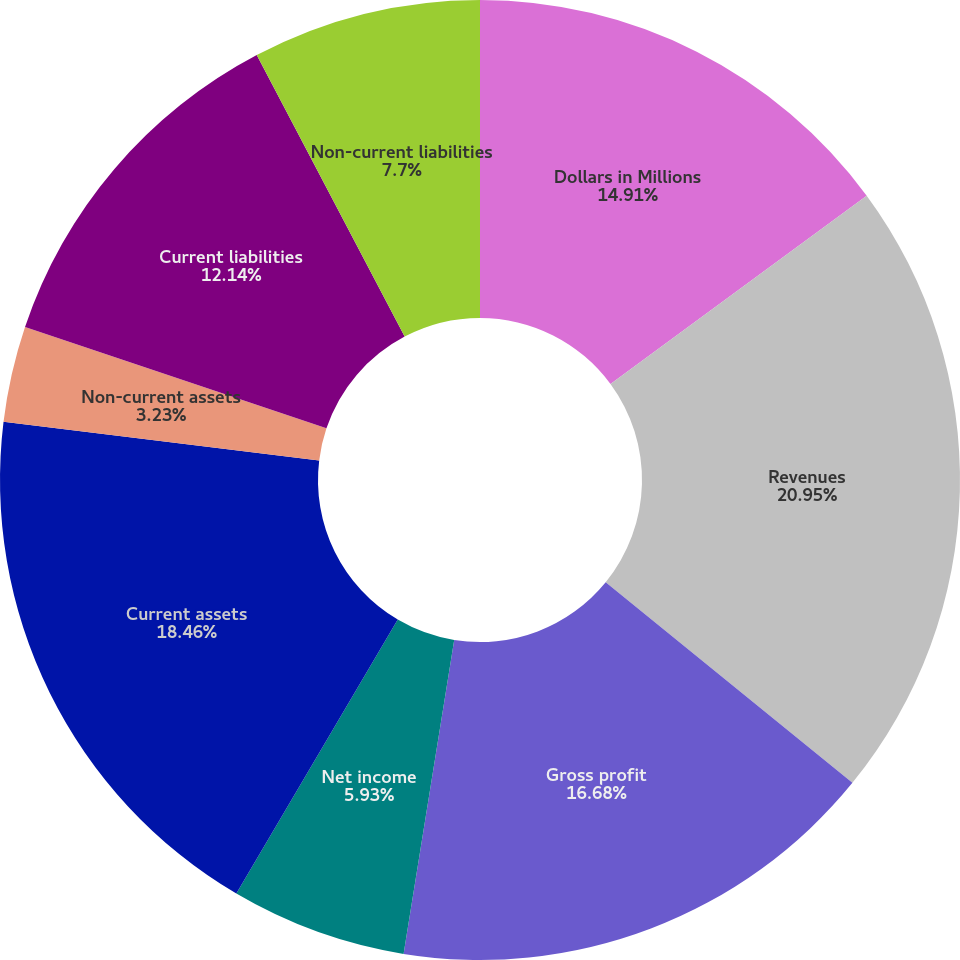Convert chart to OTSL. <chart><loc_0><loc_0><loc_500><loc_500><pie_chart><fcel>Dollars in Millions<fcel>Revenues<fcel>Gross profit<fcel>Net income<fcel>Current assets<fcel>Non-current assets<fcel>Current liabilities<fcel>Non-current liabilities<nl><fcel>14.91%<fcel>20.96%<fcel>16.68%<fcel>5.93%<fcel>18.46%<fcel>3.23%<fcel>12.14%<fcel>7.7%<nl></chart> 